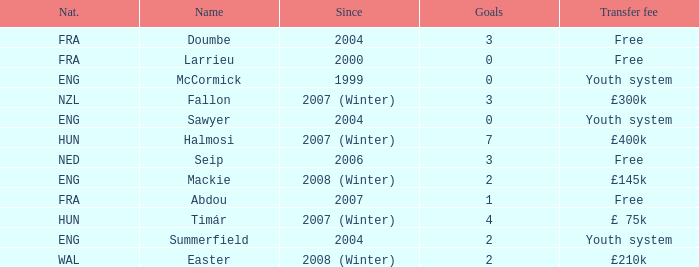What is the since year for the player with more than 3 goals and a transfer fee of £400k? 2007 (Winter). 